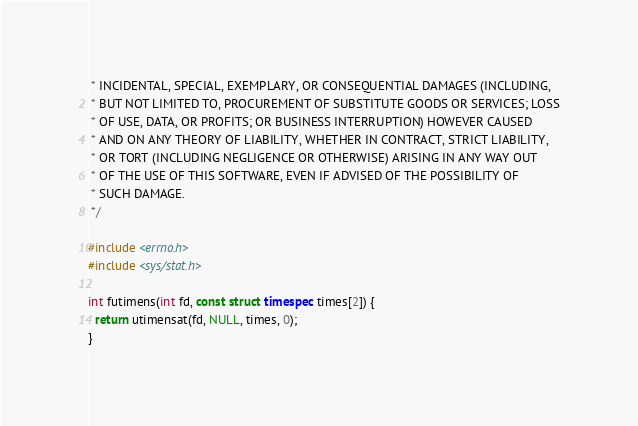Convert code to text. <code><loc_0><loc_0><loc_500><loc_500><_C++_> * INCIDENTAL, SPECIAL, EXEMPLARY, OR CONSEQUENTIAL DAMAGES (INCLUDING,
 * BUT NOT LIMITED TO, PROCUREMENT OF SUBSTITUTE GOODS OR SERVICES; LOSS
 * OF USE, DATA, OR PROFITS; OR BUSINESS INTERRUPTION) HOWEVER CAUSED
 * AND ON ANY THEORY OF LIABILITY, WHETHER IN CONTRACT, STRICT LIABILITY,
 * OR TORT (INCLUDING NEGLIGENCE OR OTHERWISE) ARISING IN ANY WAY OUT
 * OF THE USE OF THIS SOFTWARE, EVEN IF ADVISED OF THE POSSIBILITY OF
 * SUCH DAMAGE.
 */

#include <errno.h>
#include <sys/stat.h>

int futimens(int fd, const struct timespec times[2]) {
  return utimensat(fd, NULL, times, 0);
}
</code> 